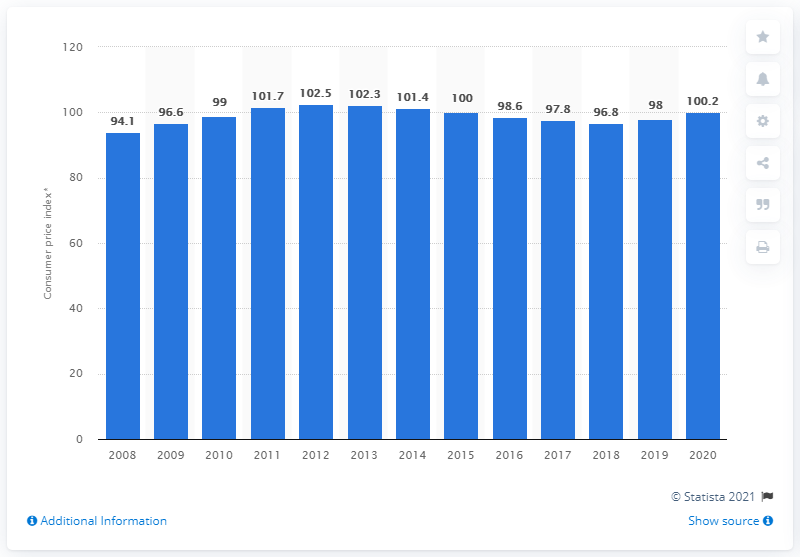Mention a couple of crucial points in this snapshot. The personal care product and appliance price index value in 2020 was 100.2. 